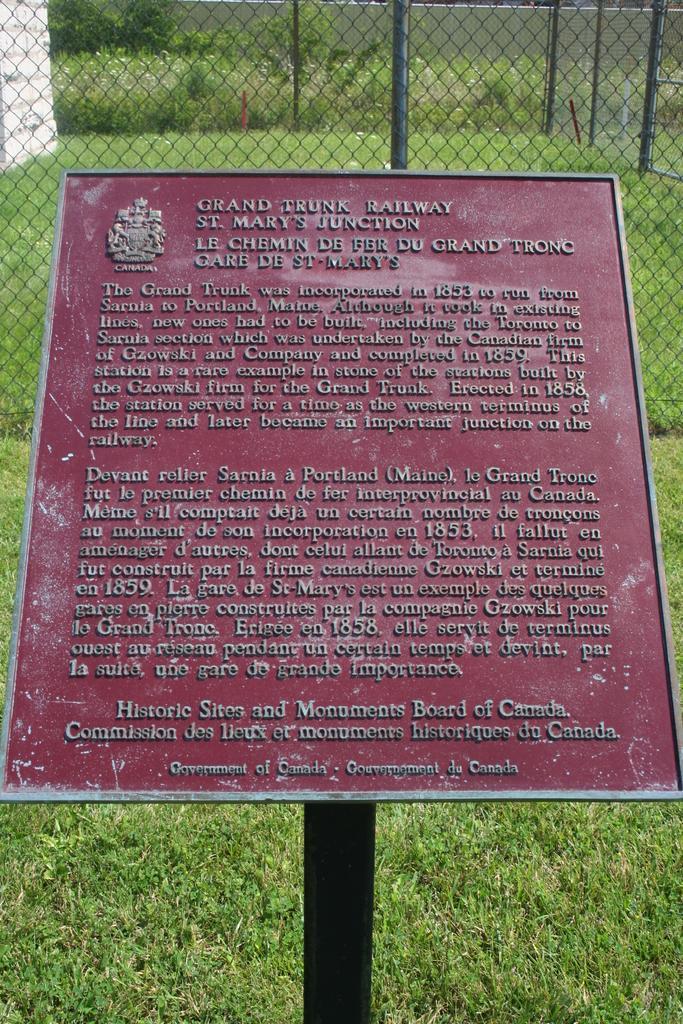Could you give a brief overview of what you see in this image? There is a board on which, there are texts. And this board is attached to the black color pole. In the background, there is grass on the ground, there is a fencing and there are plants. 